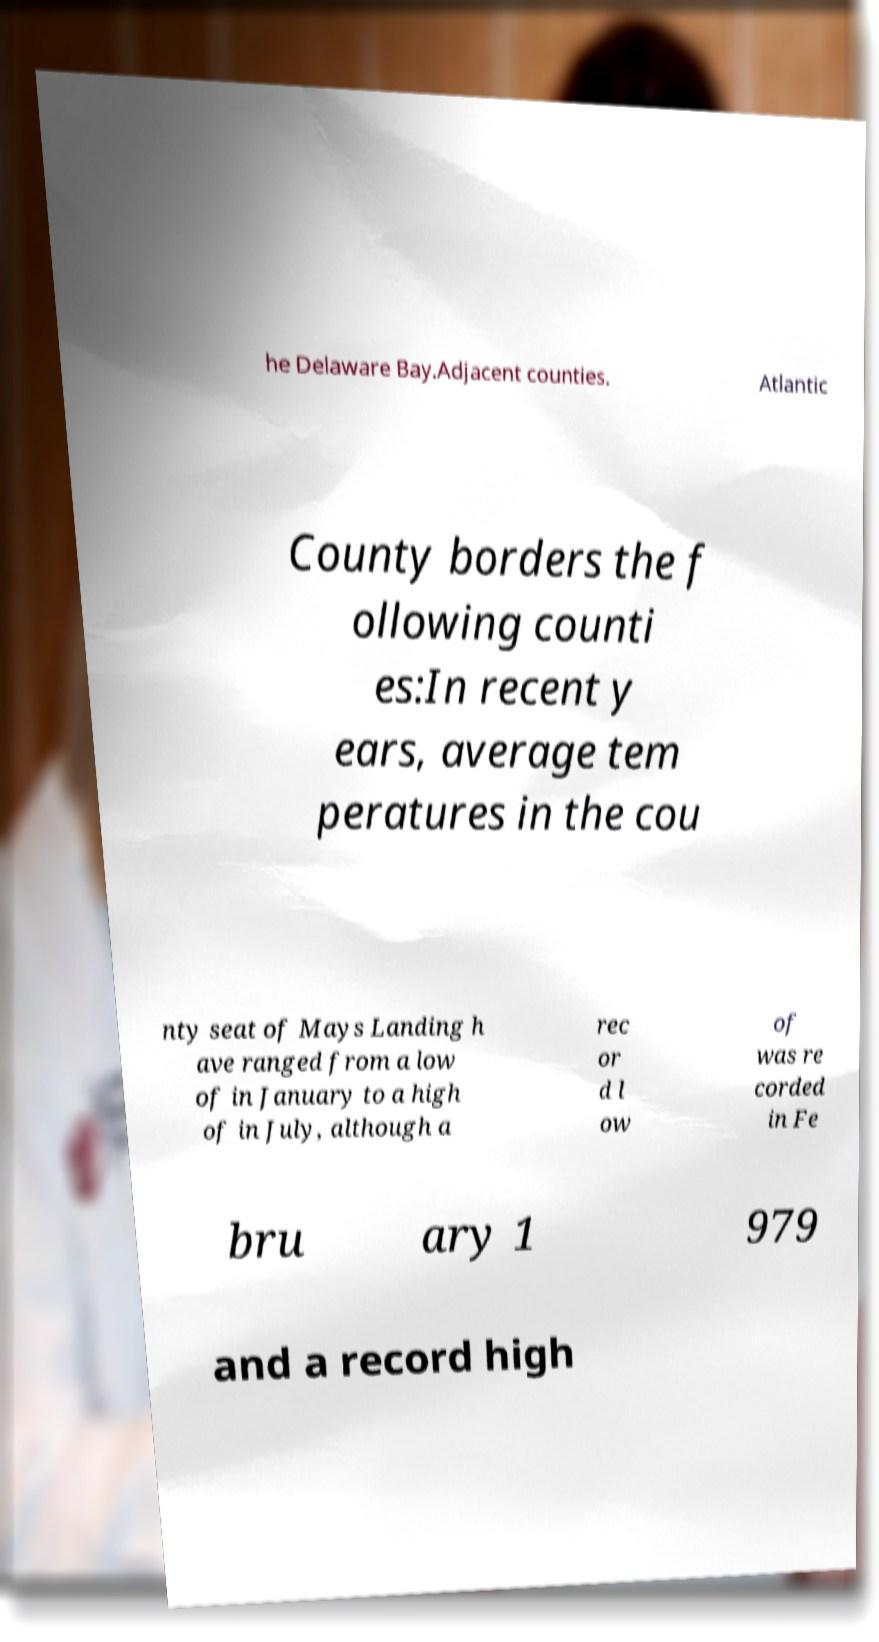Can you read and provide the text displayed in the image?This photo seems to have some interesting text. Can you extract and type it out for me? he Delaware Bay.Adjacent counties. Atlantic County borders the f ollowing counti es:In recent y ears, average tem peratures in the cou nty seat of Mays Landing h ave ranged from a low of in January to a high of in July, although a rec or d l ow of was re corded in Fe bru ary 1 979 and a record high 